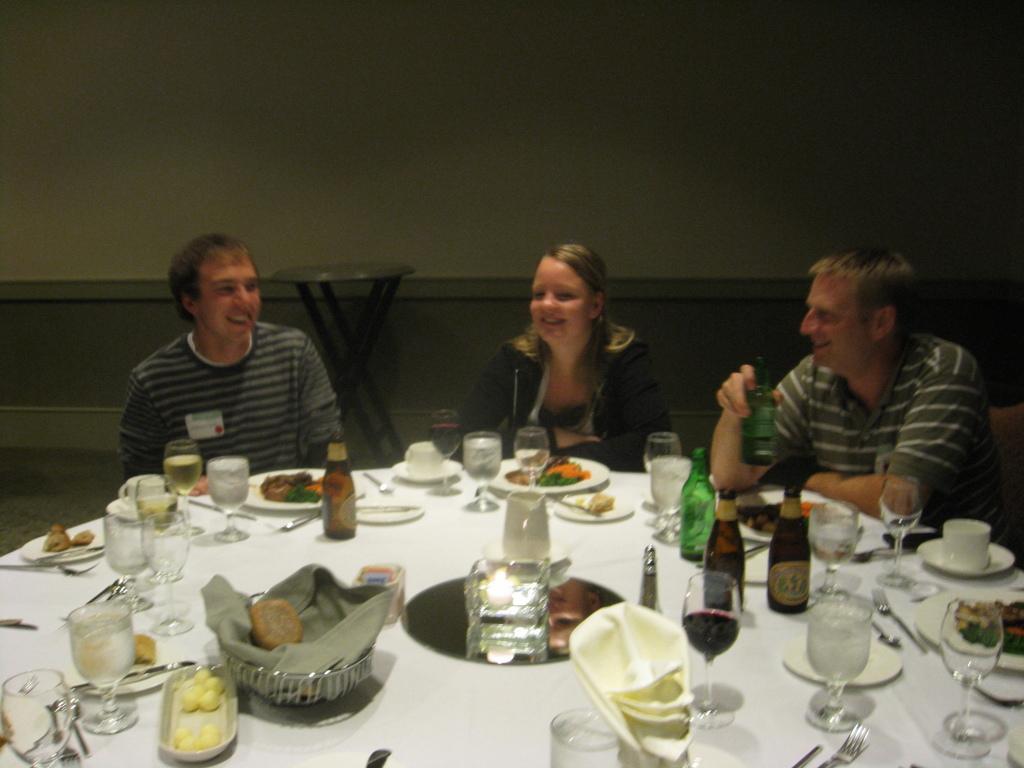Please provide a concise description of this image. In this image there are three people who are sitting around the table. On the table there are glass bottles,glasses,plates,bowl,spoon,cloth,sporks cup and food. In the background there is a wall. In front of wall there is a stool. 